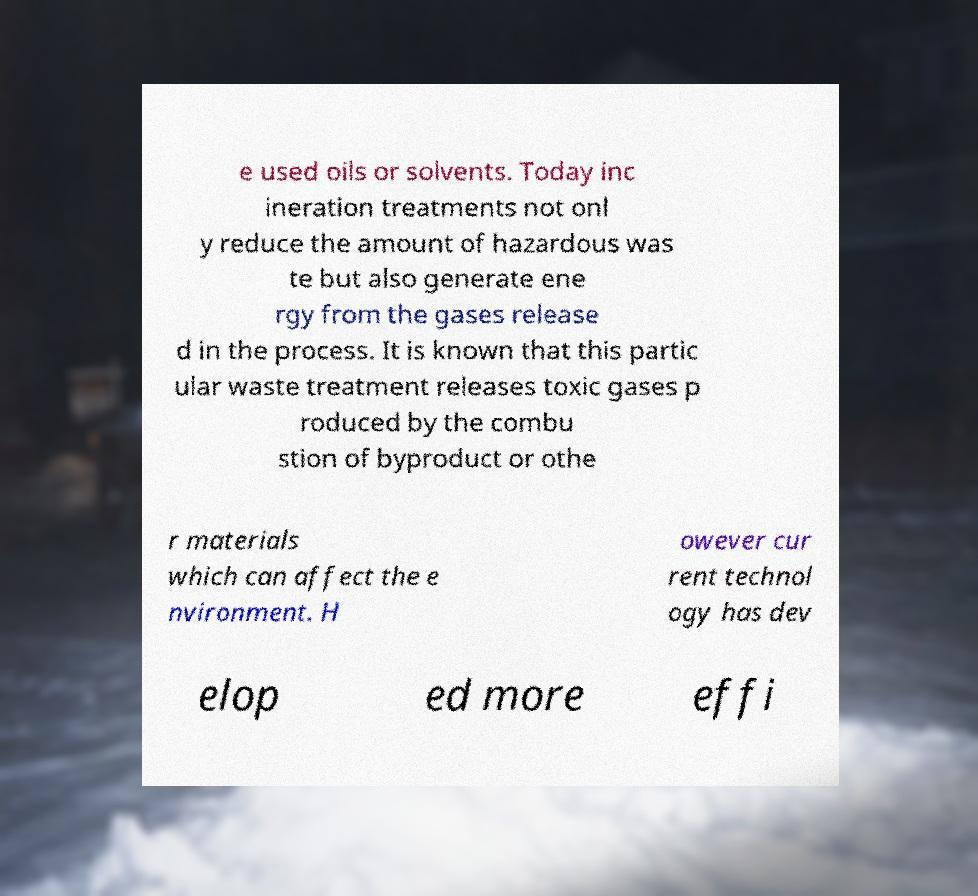Can you accurately transcribe the text from the provided image for me? e used oils or solvents. Today inc ineration treatments not onl y reduce the amount of hazardous was te but also generate ene rgy from the gases release d in the process. It is known that this partic ular waste treatment releases toxic gases p roduced by the combu stion of byproduct or othe r materials which can affect the e nvironment. H owever cur rent technol ogy has dev elop ed more effi 